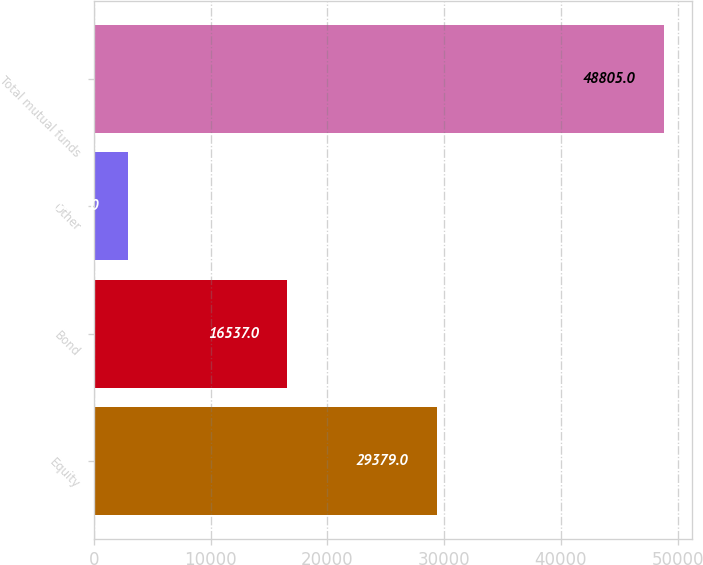Convert chart. <chart><loc_0><loc_0><loc_500><loc_500><bar_chart><fcel>Equity<fcel>Bond<fcel>Other<fcel>Total mutual funds<nl><fcel>29379<fcel>16537<fcel>2889<fcel>48805<nl></chart> 